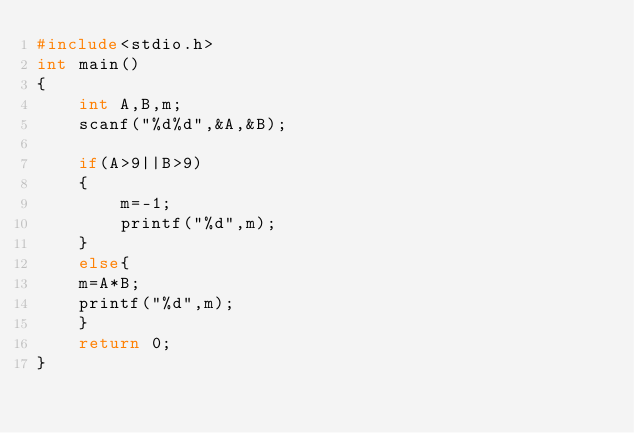<code> <loc_0><loc_0><loc_500><loc_500><_C_>#include<stdio.h>
int main()
{
    int A,B,m;
    scanf("%d%d",&A,&B);

    if(A>9||B>9)
    {
        m=-1;
        printf("%d",m);
    }
    else{
    m=A*B;
    printf("%d",m);
    }
    return 0;
}
</code> 